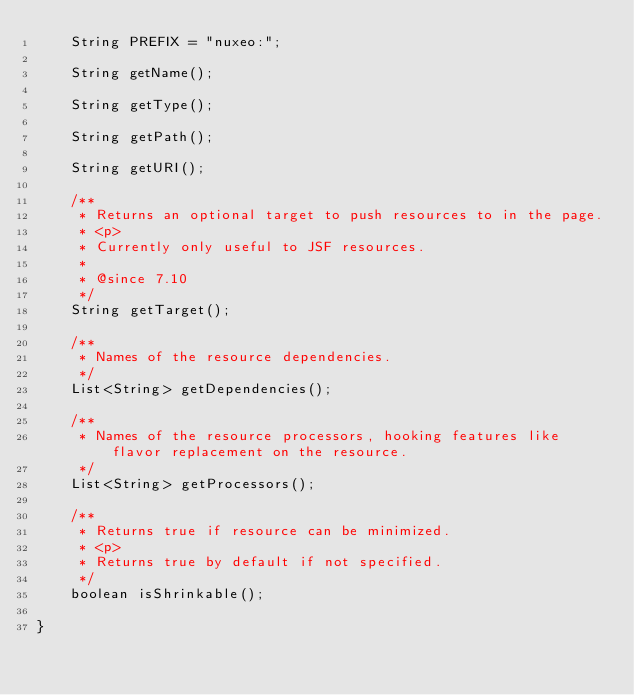<code> <loc_0><loc_0><loc_500><loc_500><_Java_>    String PREFIX = "nuxeo:";

    String getName();

    String getType();

    String getPath();

    String getURI();

    /**
     * Returns an optional target to push resources to in the page.
     * <p>
     * Currently only useful to JSF resources.
     *
     * @since 7.10
     */
    String getTarget();

    /**
     * Names of the resource dependencies.
     */
    List<String> getDependencies();

    /**
     * Names of the resource processors, hooking features like flavor replacement on the resource.
     */
    List<String> getProcessors();

    /**
     * Returns true if resource can be minimized.
     * <p>
     * Returns true by default if not specified.
     */
    boolean isShrinkable();

}
</code> 